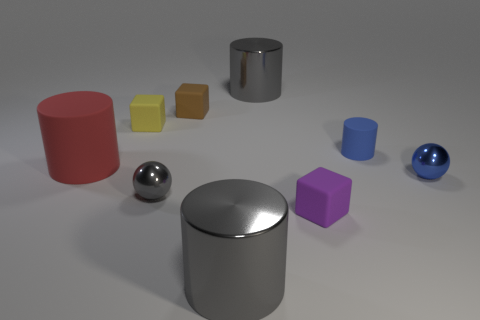Subtract all blue rubber cylinders. How many cylinders are left? 3 Subtract all gray spheres. How many gray cylinders are left? 2 Subtract 1 cylinders. How many cylinders are left? 3 Subtract all blue cylinders. How many cylinders are left? 3 Subtract all spheres. How many objects are left? 7 Subtract all red cubes. Subtract all cyan cylinders. How many cubes are left? 3 Subtract all big red cylinders. Subtract all metal cylinders. How many objects are left? 6 Add 6 yellow things. How many yellow things are left? 7 Add 8 matte balls. How many matte balls exist? 8 Subtract 1 gray spheres. How many objects are left? 8 